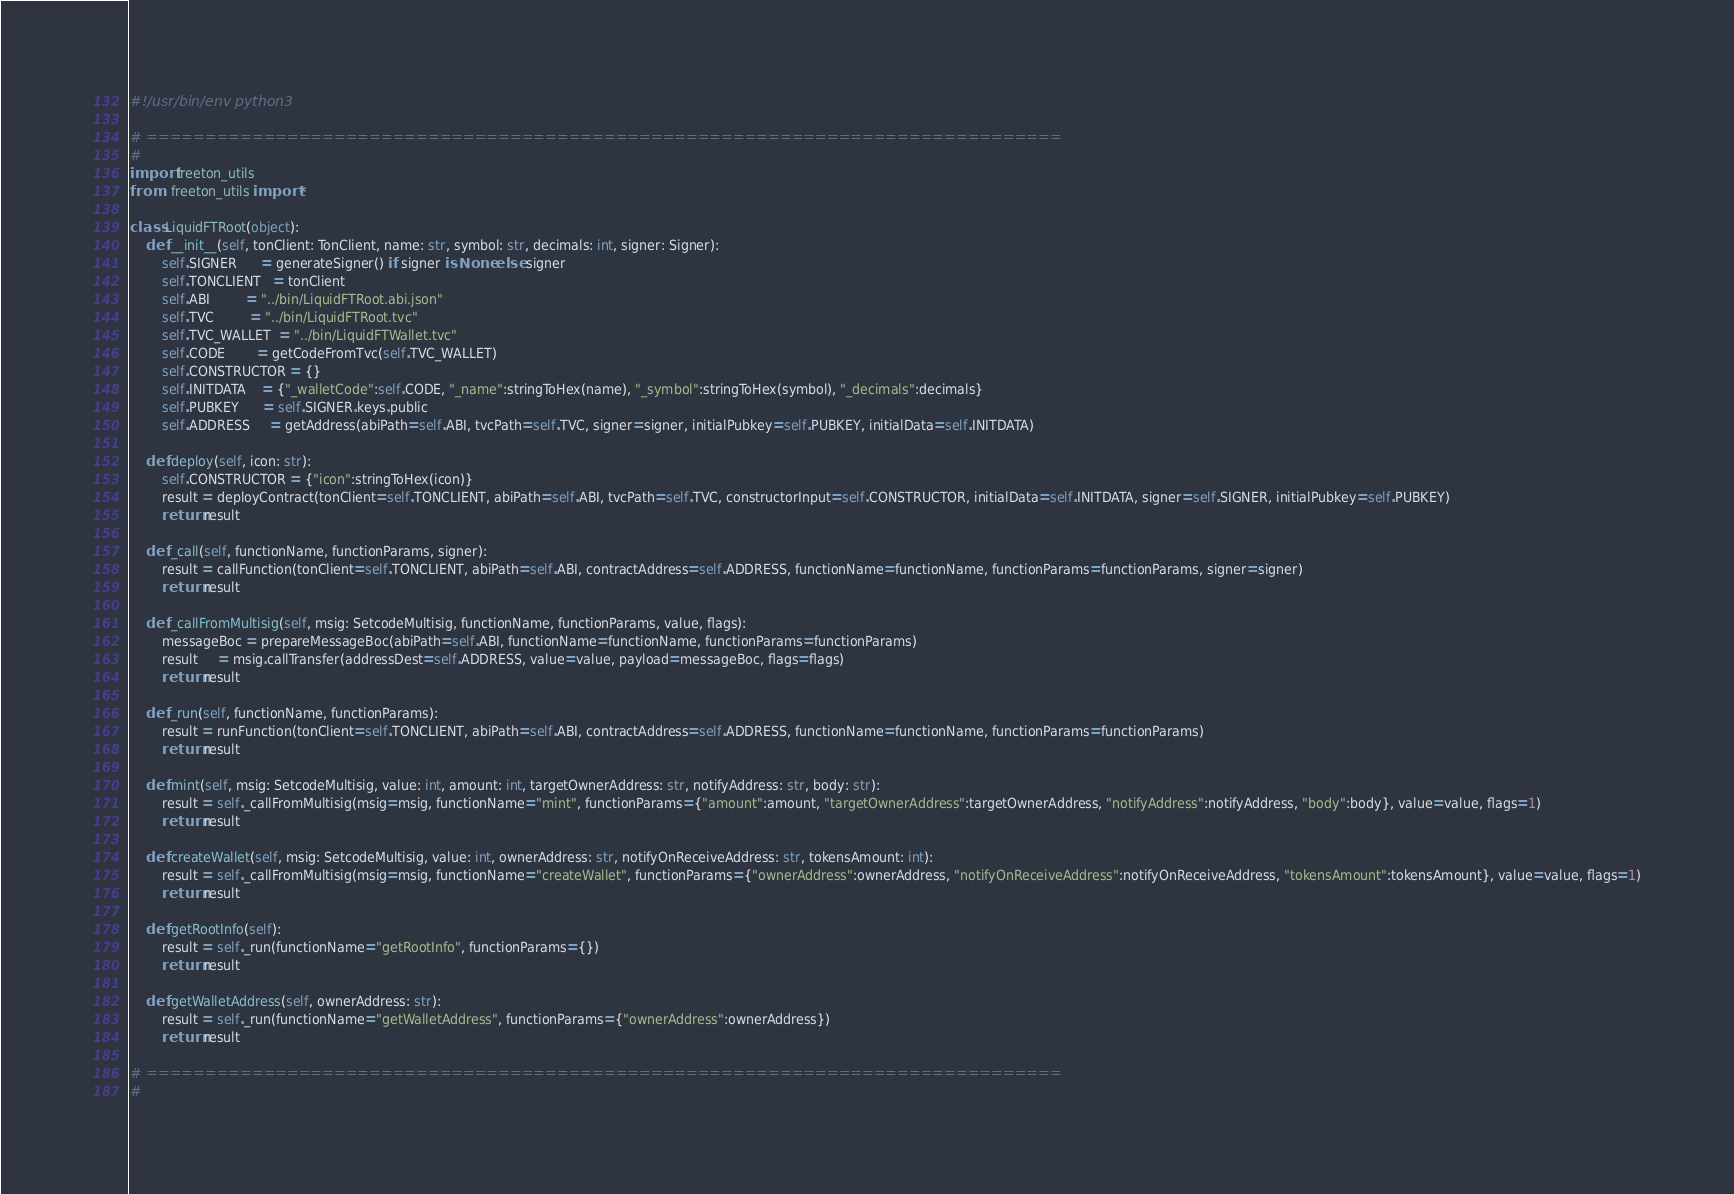<code> <loc_0><loc_0><loc_500><loc_500><_Python_>#!/usr/bin/env python3

# ==============================================================================
#
import freeton_utils
from   freeton_utils import *

class LiquidFTRoot(object):
    def __init__(self, tonClient: TonClient, name: str, symbol: str, decimals: int, signer: Signer):
        self.SIGNER      = generateSigner() if signer is None else signer
        self.TONCLIENT   = tonClient
        self.ABI         = "../bin/LiquidFTRoot.abi.json"
        self.TVC         = "../bin/LiquidFTRoot.tvc"
        self.TVC_WALLET  = "../bin/LiquidFTWallet.tvc"
        self.CODE        = getCodeFromTvc(self.TVC_WALLET)
        self.CONSTRUCTOR = {}
        self.INITDATA    = {"_walletCode":self.CODE, "_name":stringToHex(name), "_symbol":stringToHex(symbol), "_decimals":decimals}
        self.PUBKEY      = self.SIGNER.keys.public
        self.ADDRESS     = getAddress(abiPath=self.ABI, tvcPath=self.TVC, signer=signer, initialPubkey=self.PUBKEY, initialData=self.INITDATA)

    def deploy(self, icon: str):
        self.CONSTRUCTOR = {"icon":stringToHex(icon)}
        result = deployContract(tonClient=self.TONCLIENT, abiPath=self.ABI, tvcPath=self.TVC, constructorInput=self.CONSTRUCTOR, initialData=self.INITDATA, signer=self.SIGNER, initialPubkey=self.PUBKEY)
        return result
    
    def _call(self, functionName, functionParams, signer):
        result = callFunction(tonClient=self.TONCLIENT, abiPath=self.ABI, contractAddress=self.ADDRESS, functionName=functionName, functionParams=functionParams, signer=signer)
        return result

    def _callFromMultisig(self, msig: SetcodeMultisig, functionName, functionParams, value, flags):
        messageBoc = prepareMessageBoc(abiPath=self.ABI, functionName=functionName, functionParams=functionParams)
        result     = msig.callTransfer(addressDest=self.ADDRESS, value=value, payload=messageBoc, flags=flags)
        return result

    def _run(self, functionName, functionParams):
        result = runFunction(tonClient=self.TONCLIENT, abiPath=self.ABI, contractAddress=self.ADDRESS, functionName=functionName, functionParams=functionParams)
        return result

    def mint(self, msig: SetcodeMultisig, value: int, amount: int, targetOwnerAddress: str, notifyAddress: str, body: str):
        result = self._callFromMultisig(msig=msig, functionName="mint", functionParams={"amount":amount, "targetOwnerAddress":targetOwnerAddress, "notifyAddress":notifyAddress, "body":body}, value=value, flags=1)
        return result

    def createWallet(self, msig: SetcodeMultisig, value: int, ownerAddress: str, notifyOnReceiveAddress: str, tokensAmount: int):
        result = self._callFromMultisig(msig=msig, functionName="createWallet", functionParams={"ownerAddress":ownerAddress, "notifyOnReceiveAddress":notifyOnReceiveAddress, "tokensAmount":tokensAmount}, value=value, flags=1)
        return result

    def getRootInfo(self):
        result = self._run(functionName="getRootInfo", functionParams={})
        return result

    def getWalletAddress(self, ownerAddress: str):
        result = self._run(functionName="getWalletAddress", functionParams={"ownerAddress":ownerAddress})
        return result

# ==============================================================================
# 
</code> 